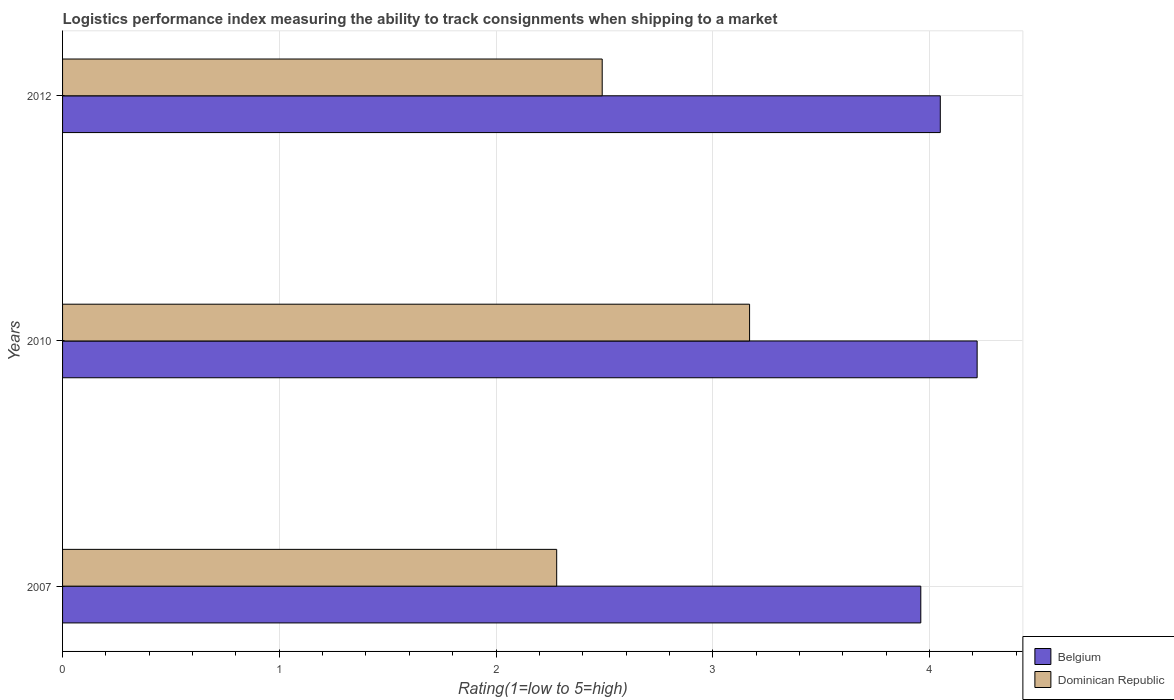How many different coloured bars are there?
Your answer should be compact. 2. How many groups of bars are there?
Offer a very short reply. 3. Are the number of bars on each tick of the Y-axis equal?
Offer a very short reply. Yes. How many bars are there on the 1st tick from the top?
Give a very brief answer. 2. What is the Logistic performance index in Dominican Republic in 2007?
Give a very brief answer. 2.28. Across all years, what is the maximum Logistic performance index in Belgium?
Give a very brief answer. 4.22. Across all years, what is the minimum Logistic performance index in Dominican Republic?
Provide a succinct answer. 2.28. In which year was the Logistic performance index in Belgium maximum?
Offer a very short reply. 2010. What is the total Logistic performance index in Belgium in the graph?
Offer a terse response. 12.23. What is the difference between the Logistic performance index in Dominican Republic in 2010 and that in 2012?
Ensure brevity in your answer.  0.68. What is the difference between the Logistic performance index in Belgium in 2007 and the Logistic performance index in Dominican Republic in 2012?
Make the answer very short. 1.47. What is the average Logistic performance index in Belgium per year?
Offer a very short reply. 4.08. In the year 2007, what is the difference between the Logistic performance index in Dominican Republic and Logistic performance index in Belgium?
Offer a terse response. -1.68. What is the ratio of the Logistic performance index in Dominican Republic in 2010 to that in 2012?
Make the answer very short. 1.27. What is the difference between the highest and the second highest Logistic performance index in Belgium?
Your answer should be compact. 0.17. What is the difference between the highest and the lowest Logistic performance index in Belgium?
Your answer should be very brief. 0.26. Is the sum of the Logistic performance index in Dominican Republic in 2010 and 2012 greater than the maximum Logistic performance index in Belgium across all years?
Your answer should be compact. Yes. What does the 1st bar from the bottom in 2012 represents?
Provide a succinct answer. Belgium. How many years are there in the graph?
Give a very brief answer. 3. What is the title of the graph?
Ensure brevity in your answer.  Logistics performance index measuring the ability to track consignments when shipping to a market. Does "Belgium" appear as one of the legend labels in the graph?
Your response must be concise. Yes. What is the label or title of the X-axis?
Make the answer very short. Rating(1=low to 5=high). What is the Rating(1=low to 5=high) in Belgium in 2007?
Your answer should be compact. 3.96. What is the Rating(1=low to 5=high) of Dominican Republic in 2007?
Ensure brevity in your answer.  2.28. What is the Rating(1=low to 5=high) in Belgium in 2010?
Ensure brevity in your answer.  4.22. What is the Rating(1=low to 5=high) in Dominican Republic in 2010?
Your answer should be very brief. 3.17. What is the Rating(1=low to 5=high) in Belgium in 2012?
Offer a terse response. 4.05. What is the Rating(1=low to 5=high) of Dominican Republic in 2012?
Provide a short and direct response. 2.49. Across all years, what is the maximum Rating(1=low to 5=high) of Belgium?
Provide a short and direct response. 4.22. Across all years, what is the maximum Rating(1=low to 5=high) of Dominican Republic?
Keep it short and to the point. 3.17. Across all years, what is the minimum Rating(1=low to 5=high) in Belgium?
Provide a short and direct response. 3.96. Across all years, what is the minimum Rating(1=low to 5=high) in Dominican Republic?
Make the answer very short. 2.28. What is the total Rating(1=low to 5=high) of Belgium in the graph?
Keep it short and to the point. 12.23. What is the total Rating(1=low to 5=high) in Dominican Republic in the graph?
Offer a terse response. 7.94. What is the difference between the Rating(1=low to 5=high) in Belgium in 2007 and that in 2010?
Provide a short and direct response. -0.26. What is the difference between the Rating(1=low to 5=high) of Dominican Republic in 2007 and that in 2010?
Ensure brevity in your answer.  -0.89. What is the difference between the Rating(1=low to 5=high) of Belgium in 2007 and that in 2012?
Your answer should be compact. -0.09. What is the difference between the Rating(1=low to 5=high) in Dominican Republic in 2007 and that in 2012?
Your response must be concise. -0.21. What is the difference between the Rating(1=low to 5=high) in Belgium in 2010 and that in 2012?
Offer a terse response. 0.17. What is the difference between the Rating(1=low to 5=high) in Dominican Republic in 2010 and that in 2012?
Your answer should be compact. 0.68. What is the difference between the Rating(1=low to 5=high) in Belgium in 2007 and the Rating(1=low to 5=high) in Dominican Republic in 2010?
Your answer should be compact. 0.79. What is the difference between the Rating(1=low to 5=high) of Belgium in 2007 and the Rating(1=low to 5=high) of Dominican Republic in 2012?
Give a very brief answer. 1.47. What is the difference between the Rating(1=low to 5=high) in Belgium in 2010 and the Rating(1=low to 5=high) in Dominican Republic in 2012?
Make the answer very short. 1.73. What is the average Rating(1=low to 5=high) of Belgium per year?
Provide a succinct answer. 4.08. What is the average Rating(1=low to 5=high) of Dominican Republic per year?
Offer a very short reply. 2.65. In the year 2007, what is the difference between the Rating(1=low to 5=high) in Belgium and Rating(1=low to 5=high) in Dominican Republic?
Provide a short and direct response. 1.68. In the year 2010, what is the difference between the Rating(1=low to 5=high) in Belgium and Rating(1=low to 5=high) in Dominican Republic?
Provide a short and direct response. 1.05. In the year 2012, what is the difference between the Rating(1=low to 5=high) of Belgium and Rating(1=low to 5=high) of Dominican Republic?
Offer a very short reply. 1.56. What is the ratio of the Rating(1=low to 5=high) in Belgium in 2007 to that in 2010?
Your response must be concise. 0.94. What is the ratio of the Rating(1=low to 5=high) of Dominican Republic in 2007 to that in 2010?
Your answer should be compact. 0.72. What is the ratio of the Rating(1=low to 5=high) of Belgium in 2007 to that in 2012?
Offer a terse response. 0.98. What is the ratio of the Rating(1=low to 5=high) in Dominican Republic in 2007 to that in 2012?
Give a very brief answer. 0.92. What is the ratio of the Rating(1=low to 5=high) of Belgium in 2010 to that in 2012?
Your answer should be very brief. 1.04. What is the ratio of the Rating(1=low to 5=high) in Dominican Republic in 2010 to that in 2012?
Provide a short and direct response. 1.27. What is the difference between the highest and the second highest Rating(1=low to 5=high) in Belgium?
Keep it short and to the point. 0.17. What is the difference between the highest and the second highest Rating(1=low to 5=high) in Dominican Republic?
Give a very brief answer. 0.68. What is the difference between the highest and the lowest Rating(1=low to 5=high) in Belgium?
Your response must be concise. 0.26. What is the difference between the highest and the lowest Rating(1=low to 5=high) in Dominican Republic?
Keep it short and to the point. 0.89. 